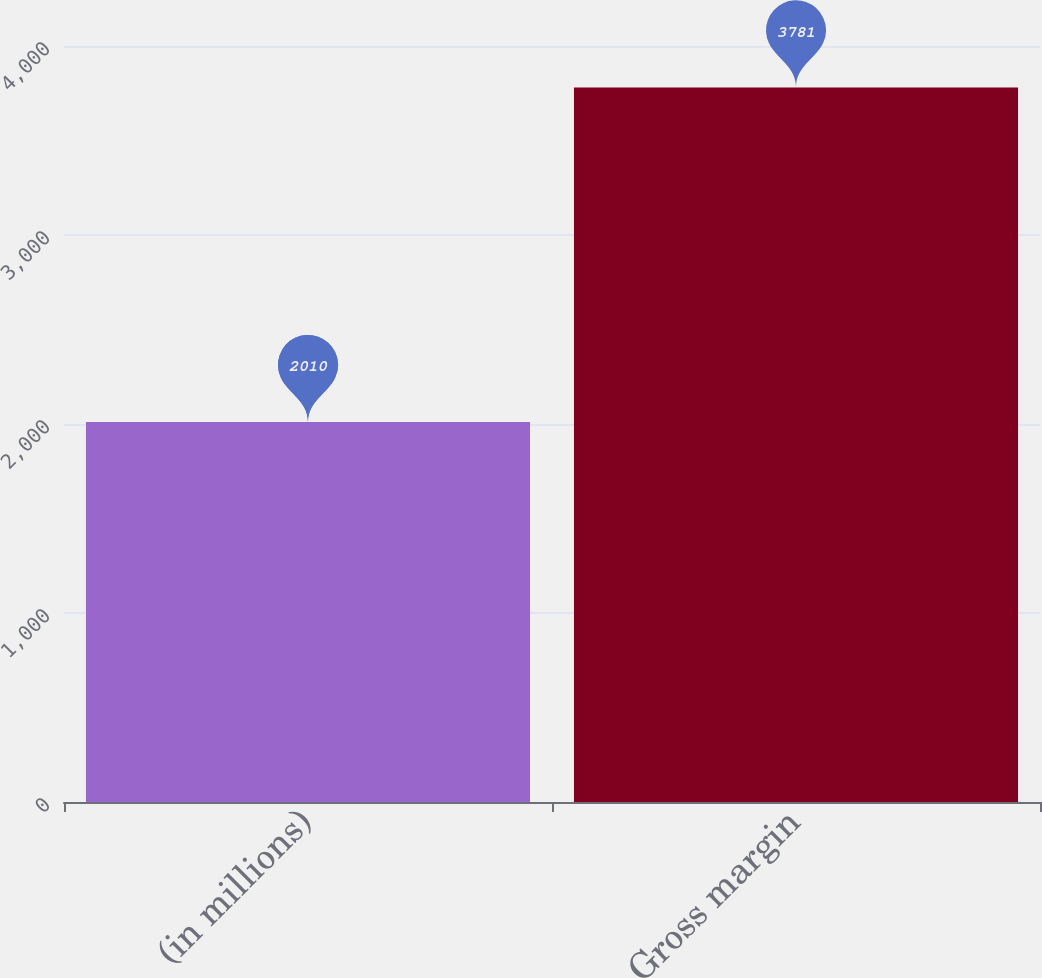Convert chart to OTSL. <chart><loc_0><loc_0><loc_500><loc_500><bar_chart><fcel>(in millions)<fcel>Gross margin<nl><fcel>2010<fcel>3781<nl></chart> 